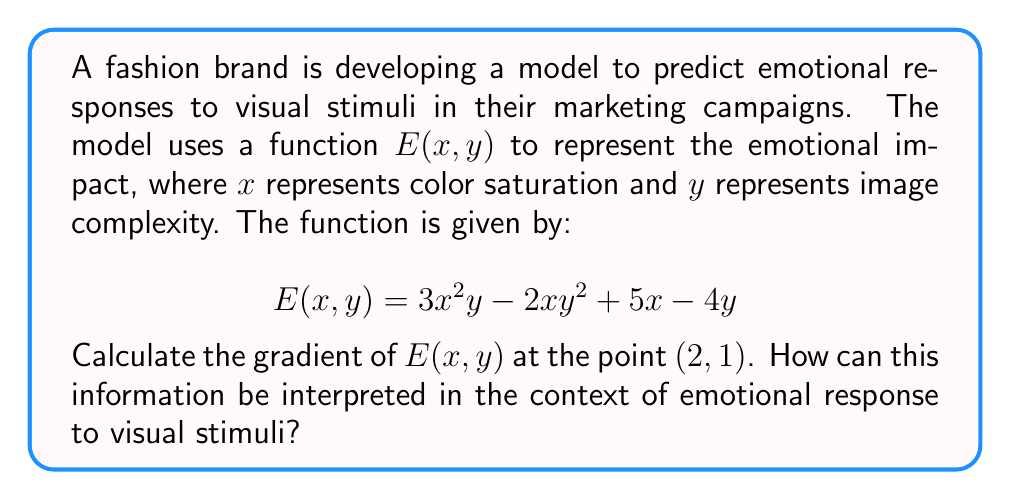Can you solve this math problem? To solve this problem, we need to follow these steps:

1) The gradient of a function $f(x, y)$ is defined as:

   $$\nabla f(x, y) = \left(\frac{\partial f}{\partial x}, \frac{\partial f}{\partial y}\right)$$

2) For our function $E(x, y) = 3x^2y - 2xy^2 + 5x - 4y$, we need to calculate the partial derivatives:

   $$\frac{\partial E}{\partial x} = 6xy - 2y^2 + 5$$
   $$\frac{\partial E}{\partial y} = 3x^2 - 4xy - 4$$

3) The gradient is therefore:

   $$\nabla E(x, y) = (6xy - 2y^2 + 5, 3x^2 - 4xy - 4)$$

4) To find the gradient at the point (2, 1), we substitute x = 2 and y = 1:

   $$\nabla E(2, 1) = (6(2)(1) - 2(1)^2 + 5, 3(2)^2 - 4(2)(1) - 4)$$
   $$= (12 - 2 + 5, 12 - 8 - 4)$$
   $$= (15, 0)$$

Interpretation: The gradient $(15, 0)$ at the point (2, 1) indicates that:

a) The emotional impact is increasing most rapidly in the x-direction (color saturation) with a rate of 15 units per unit change in x.
b) There is no change in the emotional impact with respect to y (image complexity) at this point.

This suggests that at this particular combination of color saturation and image complexity, increasing the color saturation would have a strong positive effect on emotional impact, while small changes in image complexity would have little to no effect.
Answer: The gradient of $E(x, y)$ at the point (2, 1) is $(15, 0)$. 